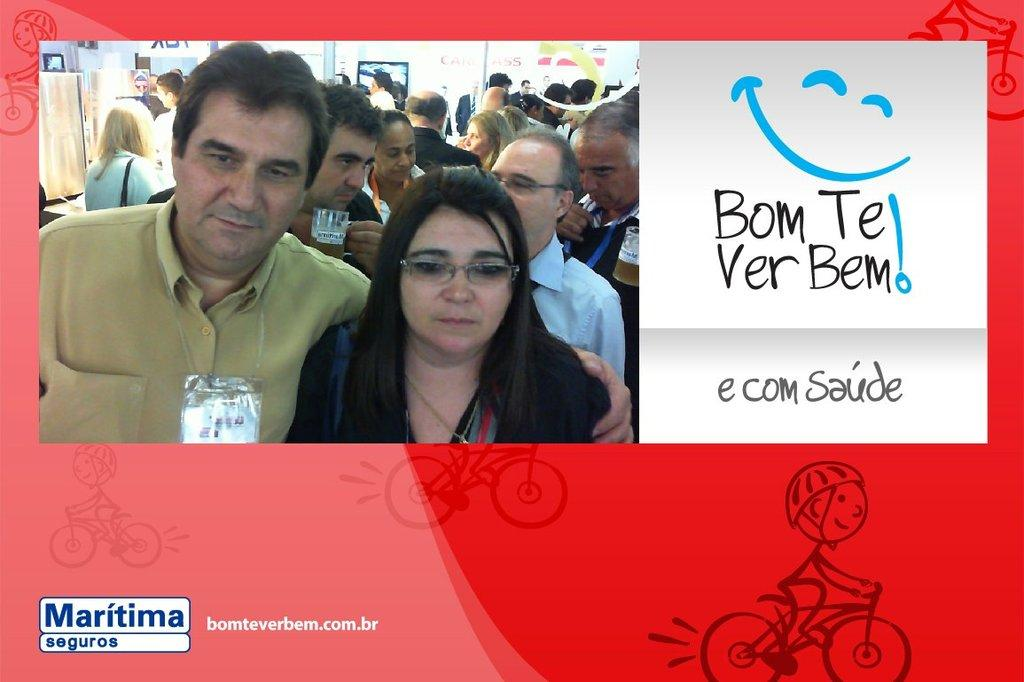What is the main subject of the image? There is an advertisement in the image. What can be seen in the advertisement? The advertisement contains persons and text. What type of illustration is present in the image? There is a cartoon in the image. What is the cartoon doing in the image? The cartoon is riding a bicycle. Where is the cartoon located in the image? The cartoon is located in the bottom right of the image. What type of thunder can be heard in the image? There is no sound present in the image, so it is not possible to hear any thunder. 